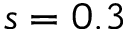Convert formula to latex. <formula><loc_0><loc_0><loc_500><loc_500>s = 0 . 3</formula> 